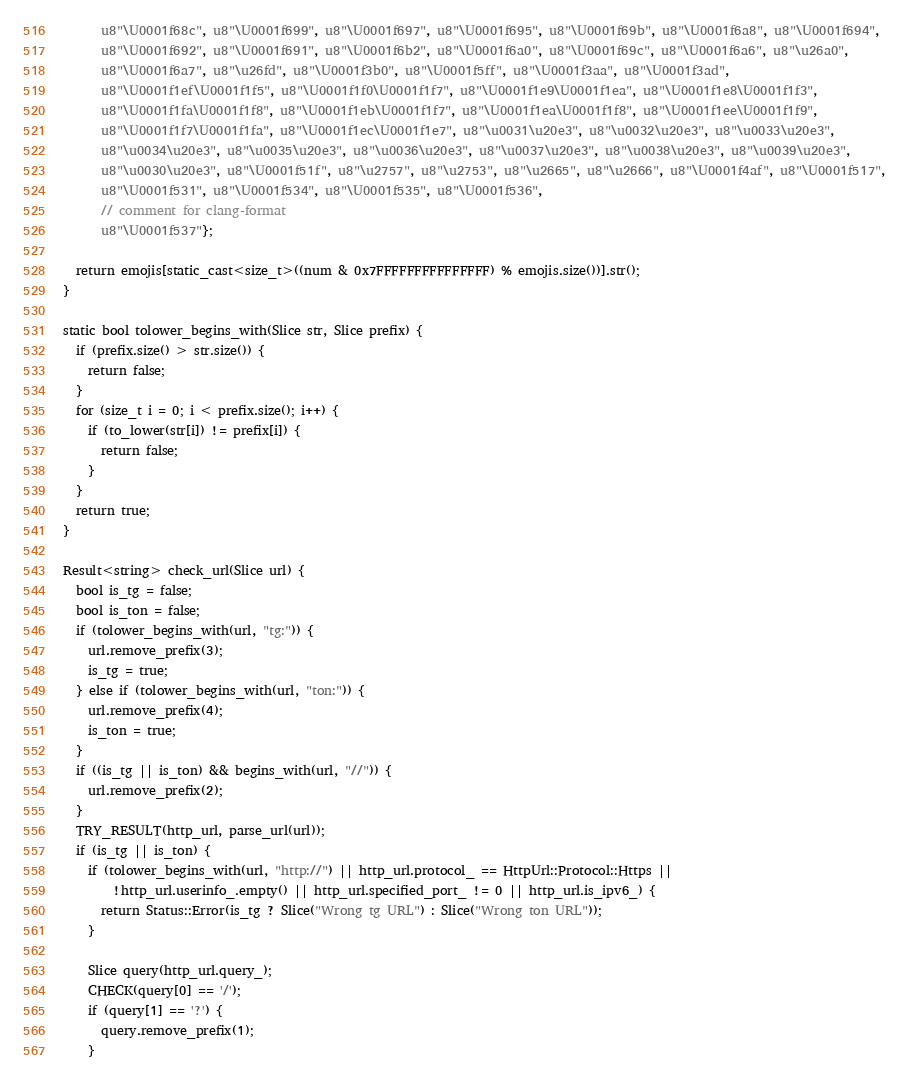Convert code to text. <code><loc_0><loc_0><loc_500><loc_500><_C++_>      u8"\U0001f68c", u8"\U0001f699", u8"\U0001f697", u8"\U0001f695", u8"\U0001f69b", u8"\U0001f6a8", u8"\U0001f694",
      u8"\U0001f692", u8"\U0001f691", u8"\U0001f6b2", u8"\U0001f6a0", u8"\U0001f69c", u8"\U0001f6a6", u8"\u26a0",
      u8"\U0001f6a7", u8"\u26fd", u8"\U0001f3b0", u8"\U0001f5ff", u8"\U0001f3aa", u8"\U0001f3ad",
      u8"\U0001f1ef\U0001f1f5", u8"\U0001f1f0\U0001f1f7", u8"\U0001f1e9\U0001f1ea", u8"\U0001f1e8\U0001f1f3",
      u8"\U0001f1fa\U0001f1f8", u8"\U0001f1eb\U0001f1f7", u8"\U0001f1ea\U0001f1f8", u8"\U0001f1ee\U0001f1f9",
      u8"\U0001f1f7\U0001f1fa", u8"\U0001f1ec\U0001f1e7", u8"\u0031\u20e3", u8"\u0032\u20e3", u8"\u0033\u20e3",
      u8"\u0034\u20e3", u8"\u0035\u20e3", u8"\u0036\u20e3", u8"\u0037\u20e3", u8"\u0038\u20e3", u8"\u0039\u20e3",
      u8"\u0030\u20e3", u8"\U0001f51f", u8"\u2757", u8"\u2753", u8"\u2665", u8"\u2666", u8"\U0001f4af", u8"\U0001f517",
      u8"\U0001f531", u8"\U0001f534", u8"\U0001f535", u8"\U0001f536",
      // comment for clang-format
      u8"\U0001f537"};

  return emojis[static_cast<size_t>((num & 0x7FFFFFFFFFFFFFFF) % emojis.size())].str();
}

static bool tolower_begins_with(Slice str, Slice prefix) {
  if (prefix.size() > str.size()) {
    return false;
  }
  for (size_t i = 0; i < prefix.size(); i++) {
    if (to_lower(str[i]) != prefix[i]) {
      return false;
    }
  }
  return true;
}

Result<string> check_url(Slice url) {
  bool is_tg = false;
  bool is_ton = false;
  if (tolower_begins_with(url, "tg:")) {
    url.remove_prefix(3);
    is_tg = true;
  } else if (tolower_begins_with(url, "ton:")) {
    url.remove_prefix(4);
    is_ton = true;
  }
  if ((is_tg || is_ton) && begins_with(url, "//")) {
    url.remove_prefix(2);
  }
  TRY_RESULT(http_url, parse_url(url));
  if (is_tg || is_ton) {
    if (tolower_begins_with(url, "http://") || http_url.protocol_ == HttpUrl::Protocol::Https ||
        !http_url.userinfo_.empty() || http_url.specified_port_ != 0 || http_url.is_ipv6_) {
      return Status::Error(is_tg ? Slice("Wrong tg URL") : Slice("Wrong ton URL"));
    }

    Slice query(http_url.query_);
    CHECK(query[0] == '/');
    if (query[1] == '?') {
      query.remove_prefix(1);
    }</code> 